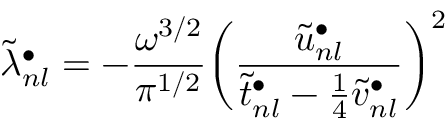Convert formula to latex. <formula><loc_0><loc_0><loc_500><loc_500>\widetilde { \lambda } _ { n l } ^ { \bullet } = - \frac { \omega ^ { 3 / 2 } } { \pi ^ { 1 / 2 } } \left ( \frac { \tilde { u } _ { n l } ^ { \bullet } } { \tilde { t } _ { n l } ^ { \bullet } - \frac { 1 } { 4 } \tilde { v } _ { n l } ^ { \bullet } } \right ) ^ { 2 }</formula> 